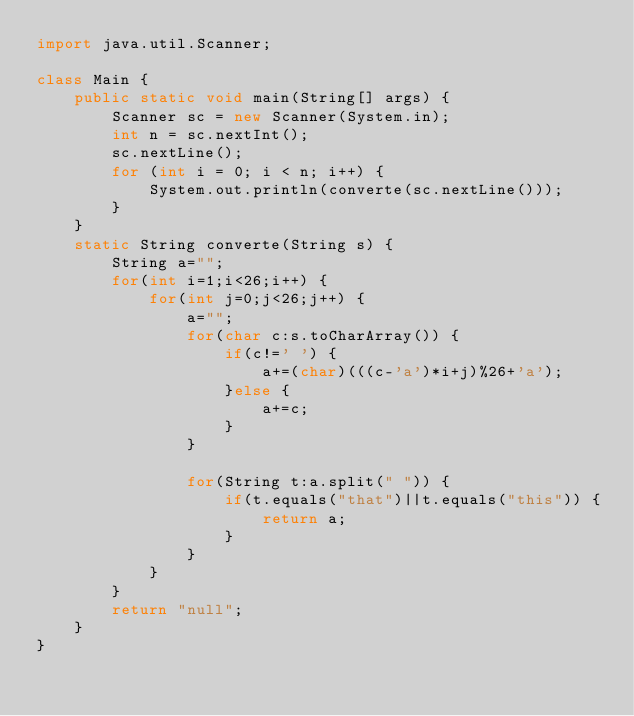<code> <loc_0><loc_0><loc_500><loc_500><_Java_>import java.util.Scanner;

class Main {
    public static void main(String[] args) {
        Scanner sc = new Scanner(System.in);
        int n = sc.nextInt();
        sc.nextLine();
        for (int i = 0; i < n; i++) {
            System.out.println(converte(sc.nextLine()));
        }
    }
    static String converte(String s) {
        String a="";
        for(int i=1;i<26;i++) {
            for(int j=0;j<26;j++) {
                a="";
                for(char c:s.toCharArray()) {
                    if(c!=' ') {
                        a+=(char)(((c-'a')*i+j)%26+'a');                
                    }else {
                        a+=c;
                    }
                }

                for(String t:a.split(" ")) {
                    if(t.equals("that")||t.equals("this")) {
                        return a;
                    }
                }
            }
        }
        return "null";
    }
}
</code> 